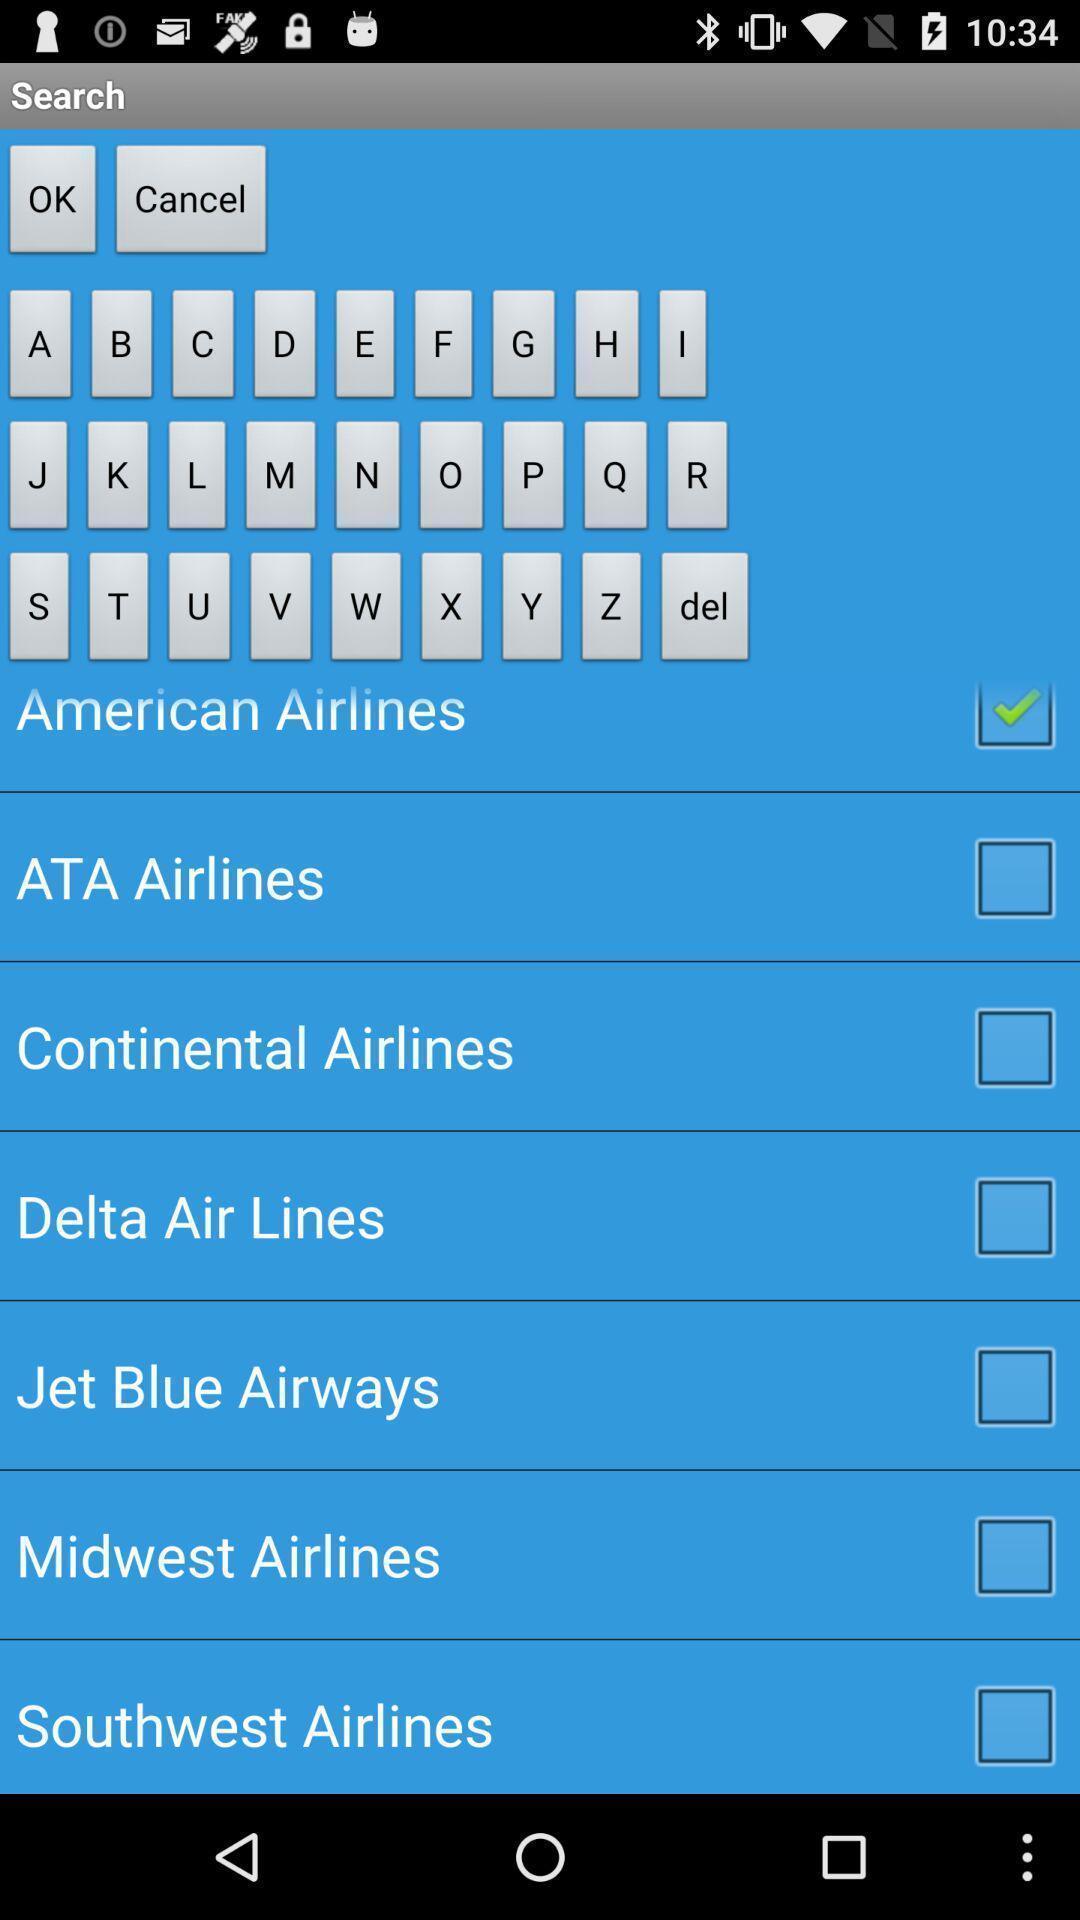Explain the elements present in this screenshot. Screen displaying list of airlines. 